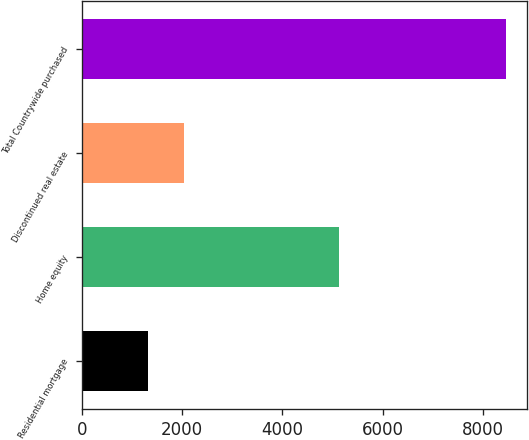<chart> <loc_0><loc_0><loc_500><loc_500><bar_chart><fcel>Residential mortgage<fcel>Home equity<fcel>Discontinued real estate<fcel>Total Countrywide purchased<nl><fcel>1331<fcel>5129<fcel>2043.8<fcel>8459<nl></chart> 